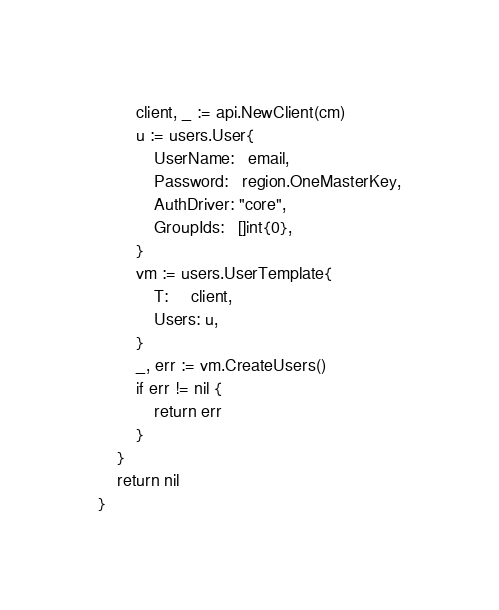<code> <loc_0><loc_0><loc_500><loc_500><_Go_>		client, _ := api.NewClient(cm)
		u := users.User{
			UserName:   email,
			Password:   region.OneMasterKey,
			AuthDriver: "core",
			GroupIds:   []int{0},
		}
		vm := users.UserTemplate{
			T:     client,
			Users: u,
		}
		_, err := vm.CreateUsers()
		if err != nil {
			return err
		}
	}
	return nil
}
</code> 